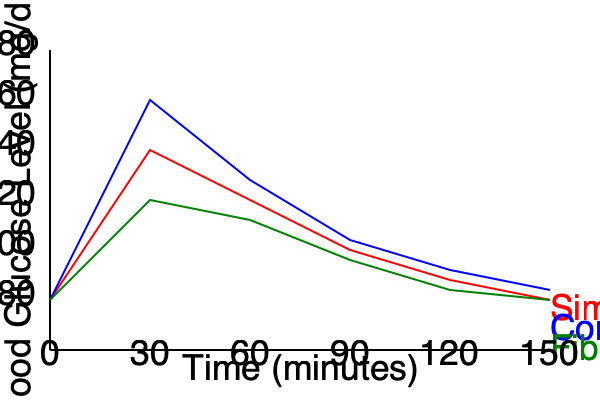Based on the graph, which type of carbohydrate leads to the most stable blood glucose levels over the 150-minute period, and what nutritional recommendation would you make to a patient with diabetes to help manage their blood sugar? To answer this question, we need to analyze the graph and interpret the blood glucose level trends for each type of carbohydrate:

1. Simple sugars (red line):
   - Rapid spike in blood glucose, peaking around 30 minutes
   - Sharp decline followed by a gradual decrease
   - Highest overall glucose levels

2. Complex carbs (blue line):
   - Faster initial rise than simple sugars, but lower peak
   - More gradual decline compared to simple sugars
   - Moderate overall glucose levels

3. Fiber-rich carbs (green line):
   - Slowest initial rise in blood glucose
   - Lowest peak glucose level
   - Most gradual decline and stabilization
   - Lowest overall glucose levels

The fiber-rich carbohydrates show the most stable blood glucose levels over the 150-minute period. This is evident from the following observations:
   - The green line has the smallest variation in glucose levels
   - It has the lowest peak and the most gradual changes

For a patient with diabetes, stable blood glucose levels are crucial for managing their condition. Therefore, the nutritional recommendation would be to prioritize fiber-rich carbohydrates in their diet.

Fiber-rich carbohydrates have several benefits for diabetes management:
1. Slower digestion and absorption, leading to a more gradual rise in blood sugar
2. Improved insulin sensitivity
3. Increased satiety, which can help with weight management
4. Potential reduction in cholesterol levels

Examples of fiber-rich carbohydrates to recommend include:
- Whole grains (e.g., brown rice, quinoa, oats)
- Legumes (e.g., lentils, beans, chickpeas)
- Vegetables (e.g., broccoli, Brussels sprouts, carrots)
- Fruits with edible skins and seeds (e.g., berries, apples, pears)

By emphasizing these foods, patients with diabetes can better manage their blood glucose levels and potentially reduce the risk of complications associated with the disease.
Answer: Fiber-rich carbohydrates; recommend prioritizing fiber-rich carbs in the diet for stable blood glucose levels. 